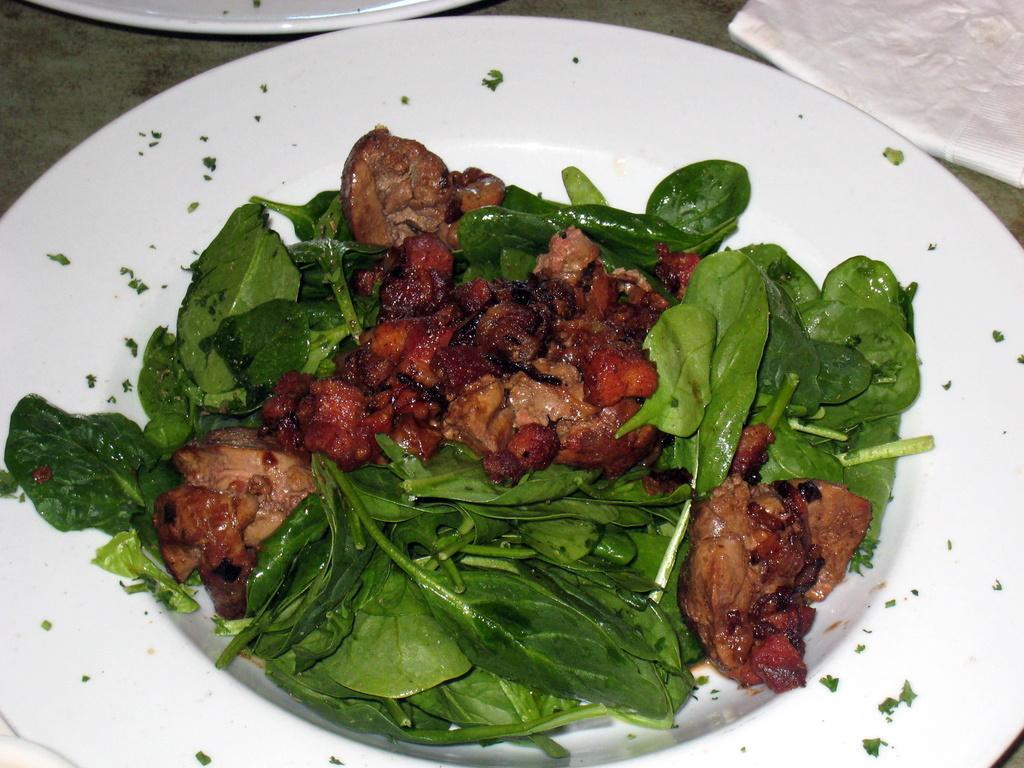Describe this image in one or two sentences. In the foreground of the picture there is a plate, in the plate there are leaves and a food item. At the top there is a tissue paper and a plate. 